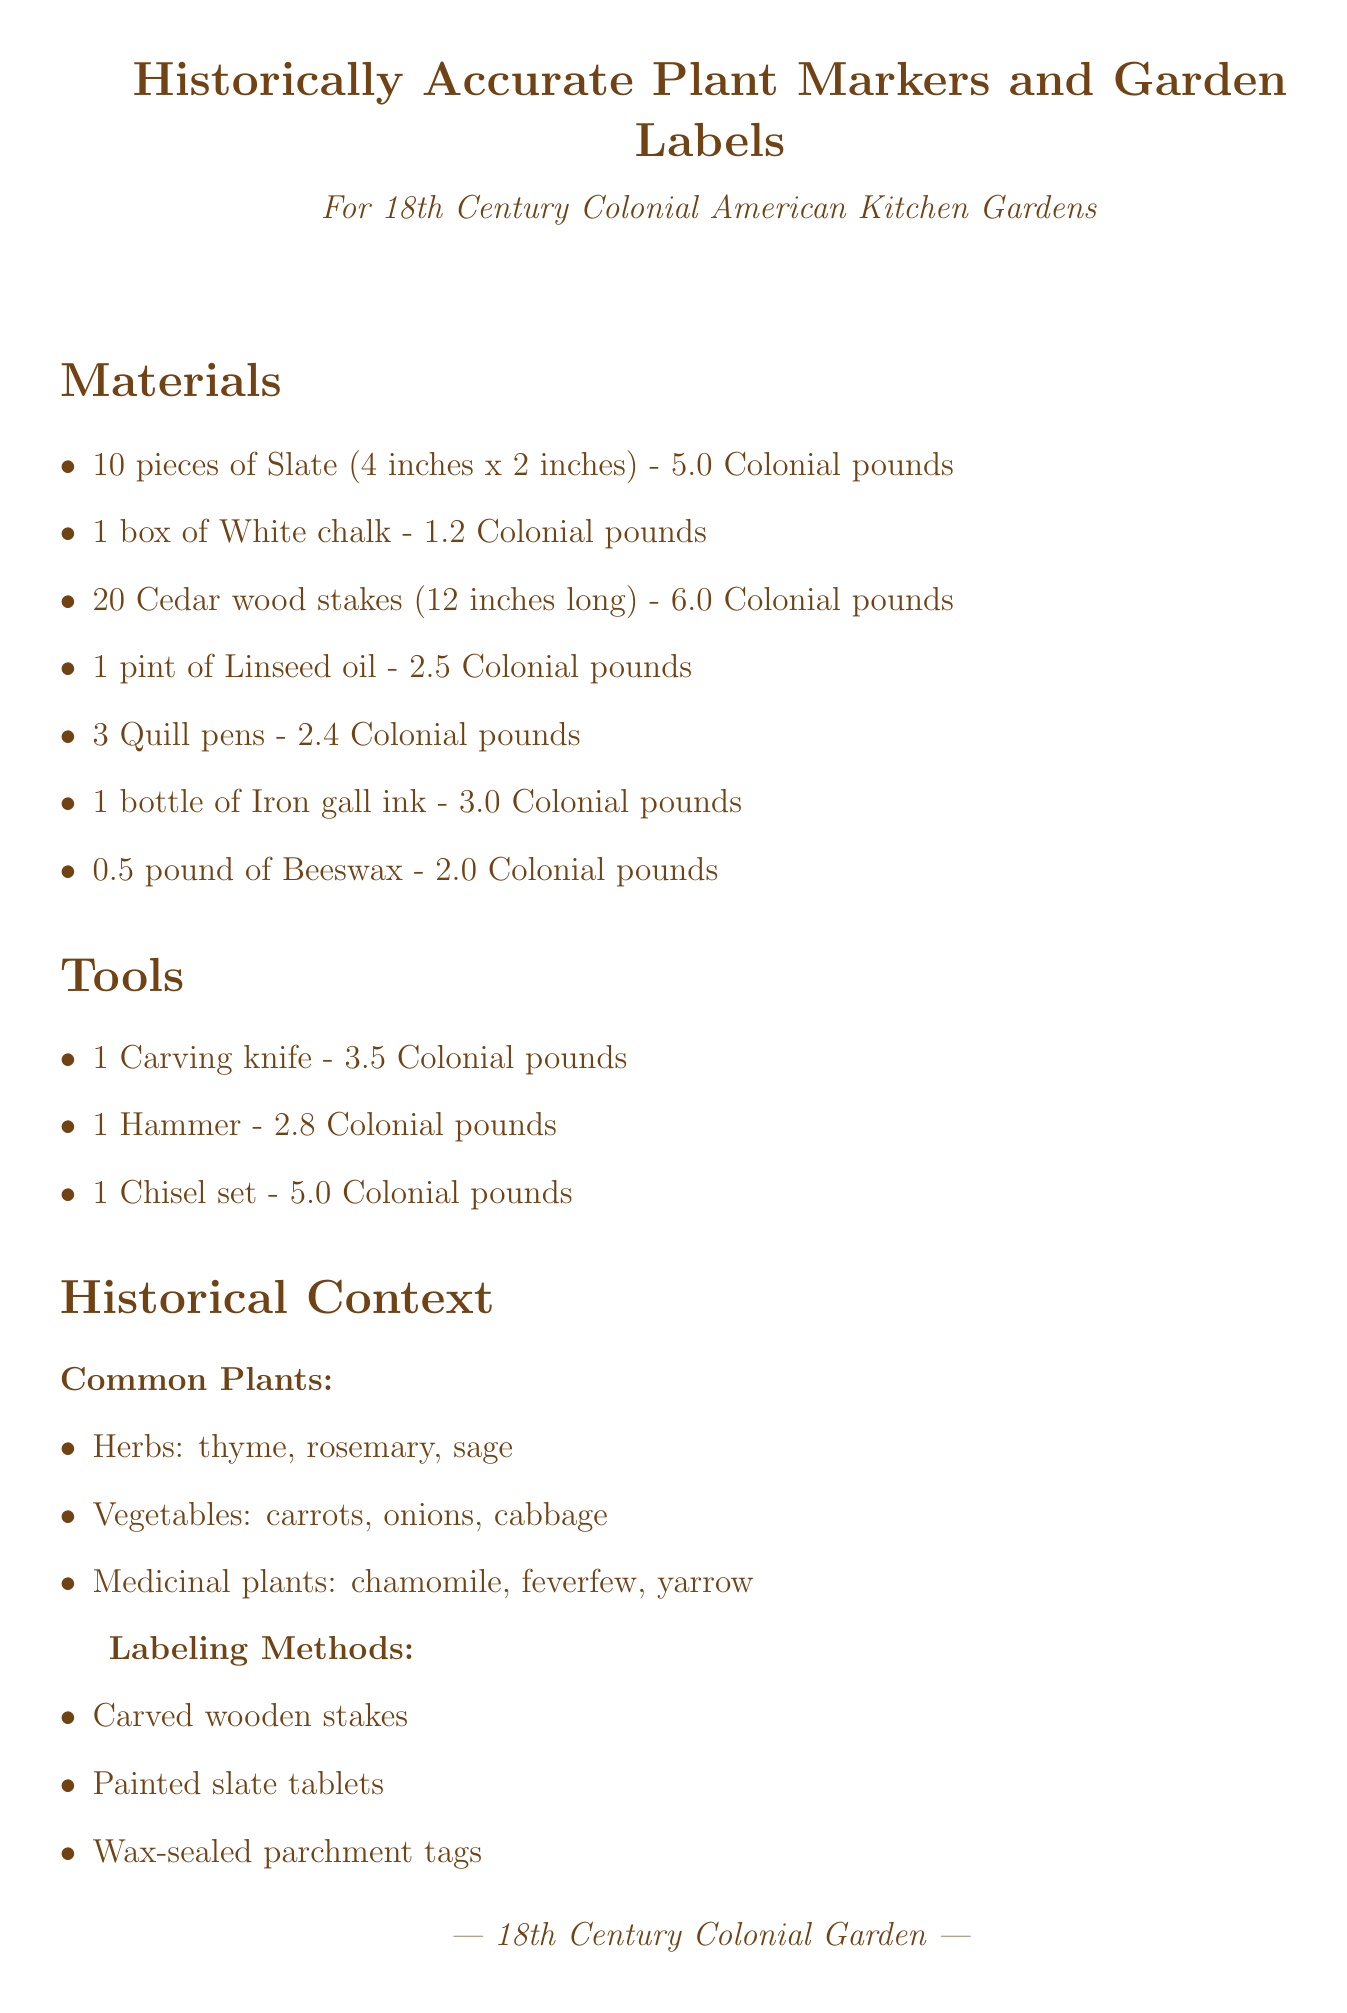What is the total cost? The total cost is listed at the bottom of the document.
Answer: 33.4 Colonial pounds What materials are used for temporary labels? The additional notes mention the use of certain materials for temporary labels.
Answer: Slate and chalk How many Cedar wood stakes are included in the purchase? The materials section specifies the quantity of Cedar wood stakes.
Answer: 20 pieces What tool is needed for carving? The tools section lists items, including the specific tool required for carving.
Answer: Carving knife What is the size of the Slate pieces? The details about Slate provide the dimensions of each piece.
Answer: 4 inches x 2 inches What should be applied to wooden stakes for weather protection? The additional notes recommend a specific treatment for wooden stakes.
Answer: Linseed oil What are common herbs listed in the historical context? The historical context section mentions specific categories of plants, including herbs.
Answer: Thyme, rosemary, sage How much White chalk is included? The materials section specifies the quantity of White chalk included in the purchase.
Answer: 1 box 